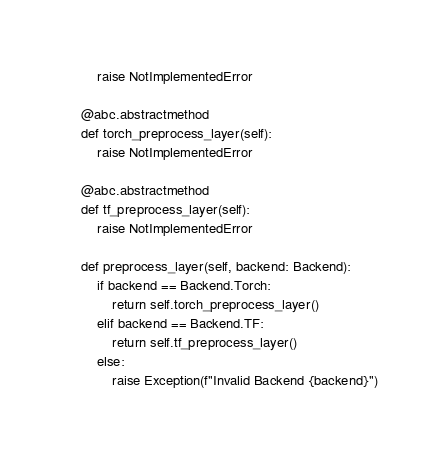Convert code to text. <code><loc_0><loc_0><loc_500><loc_500><_Python_>        raise NotImplementedError

    @abc.abstractmethod
    def torch_preprocess_layer(self):
        raise NotImplementedError

    @abc.abstractmethod
    def tf_preprocess_layer(self):
        raise NotImplementedError

    def preprocess_layer(self, backend: Backend):
        if backend == Backend.Torch:
            return self.torch_preprocess_layer()
        elif backend == Backend.TF:
            return self.tf_preprocess_layer()
        else:
            raise Exception(f"Invalid Backend {backend}")
</code> 